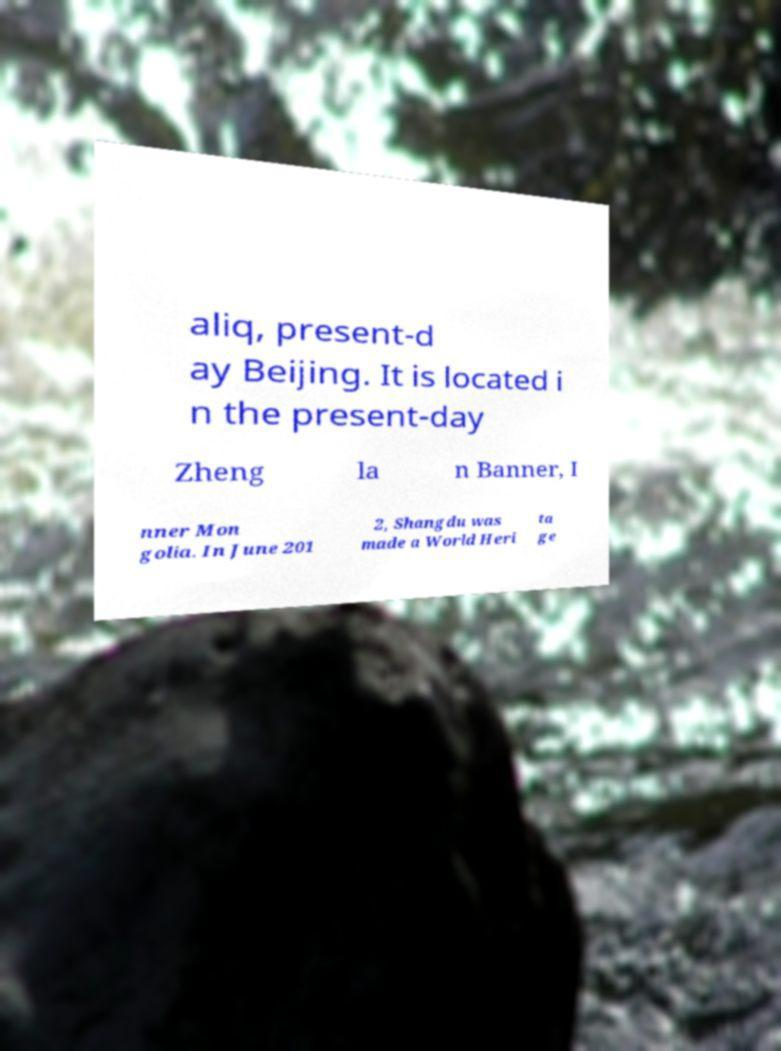For documentation purposes, I need the text within this image transcribed. Could you provide that? aliq, present-d ay Beijing. It is located i n the present-day Zheng la n Banner, I nner Mon golia. In June 201 2, Shangdu was made a World Heri ta ge 